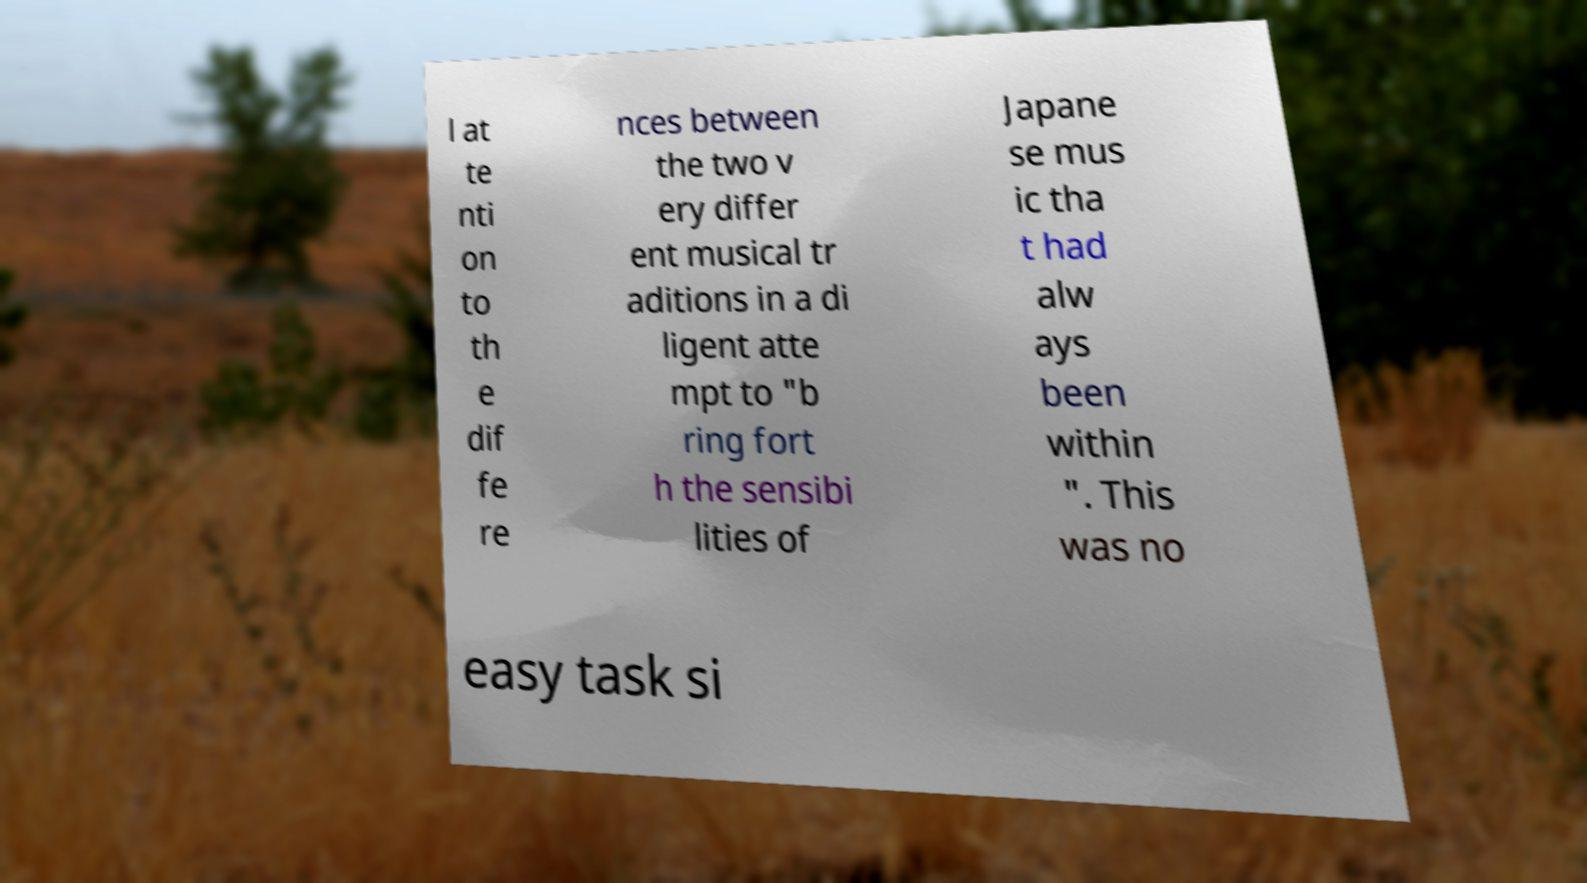Could you extract and type out the text from this image? l at te nti on to th e dif fe re nces between the two v ery differ ent musical tr aditions in a di ligent atte mpt to "b ring fort h the sensibi lities of Japane se mus ic tha t had alw ays been within ". This was no easy task si 